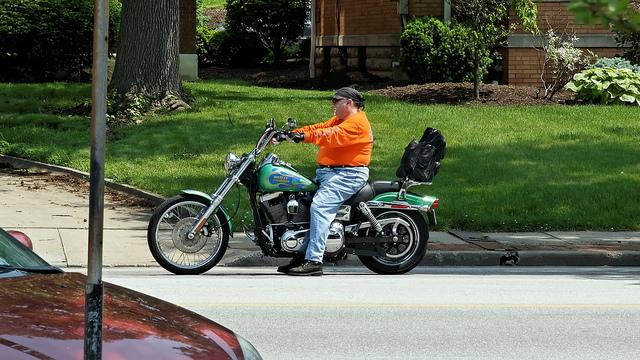What is on the back of the motorcycle? Please explain your reasoning. backpack. The object is shaped like a school bag meant to carry things in it. 